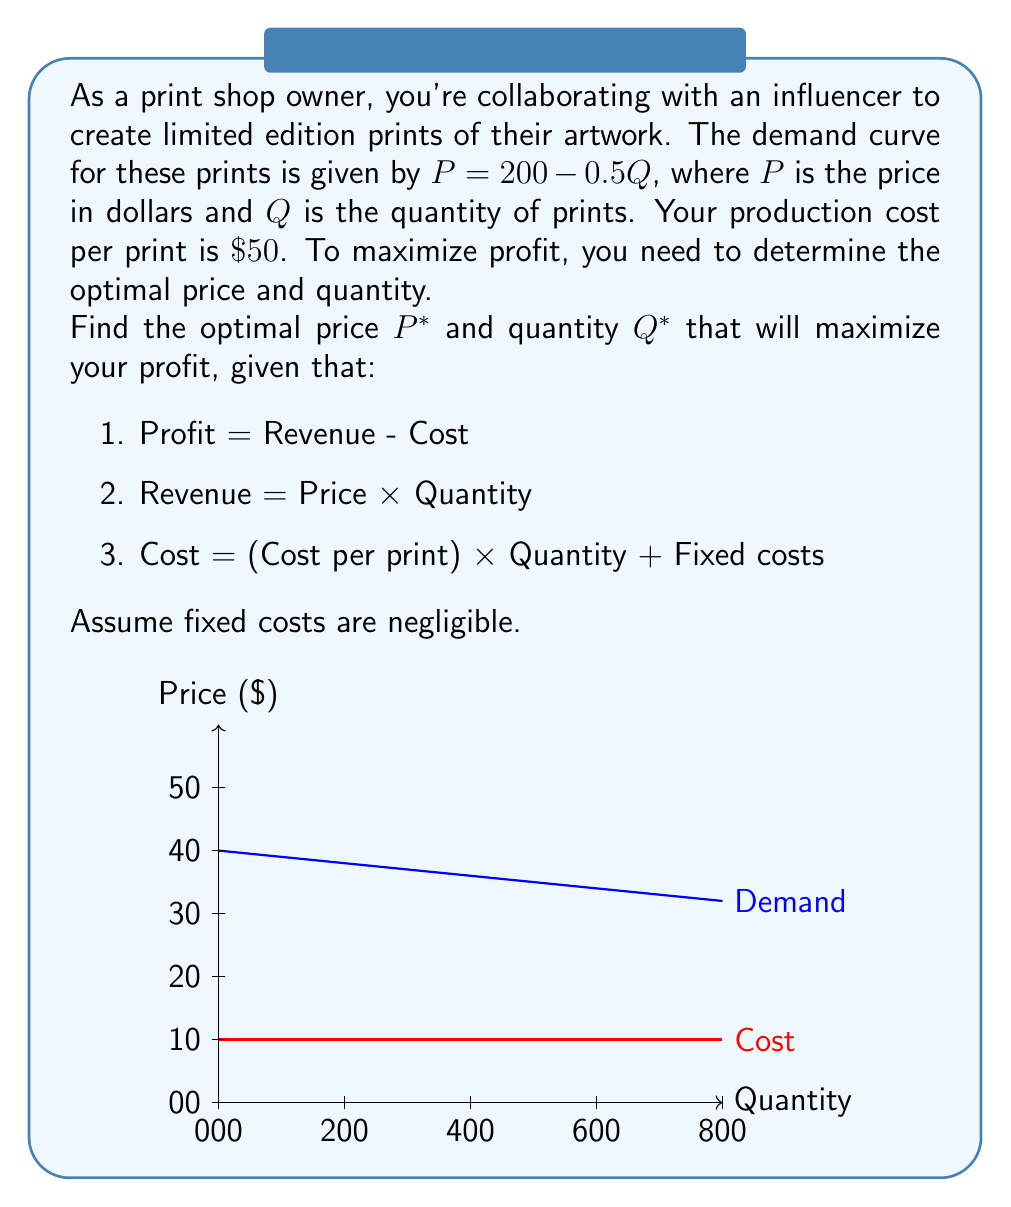Could you help me with this problem? Let's approach this step-by-step:

1) The demand function is $P = 200 - 0.5Q$. We can rearrange this to express $Q$ in terms of $P$:
   $Q = 400 - 2P$

2) Revenue (R) is price times quantity:
   $R = P \cdot Q = P(400 - 2P) = 400P - 2P^2$

3) Cost (C) is $50 per print, so:
   $C = 50Q = 50(400 - 2P) = 20000 - 100P$

4) Profit (π) is Revenue minus Cost:
   $π = R - C = (400P - 2P^2) - (20000 - 100P)$
   $π = 400P - 2P^2 - 20000 + 100P$
   $π = 500P - 2P^2 - 20000$

5) To maximize profit, we find where the derivative of profit with respect to price is zero:
   $\frac{dπ}{dP} = 500 - 4P$
   Set this equal to zero: $500 - 4P = 0$
   Solve for P: $4P = 500$, so $P^* = 125$

6) To find $Q^*$, we substitute $P^* = 125$ into our demand equation:
   $Q^* = 400 - 2(125) = 150$

7) We can verify this is a maximum by checking the second derivative:
   $\frac{d^2π}{dP^2} = -4$, which is negative, confirming a maximum.

Therefore, the optimal price is $\$125$ and the optimal quantity is 150 prints.
Answer: $P^* = \$125$, $Q^* = 150$ prints 